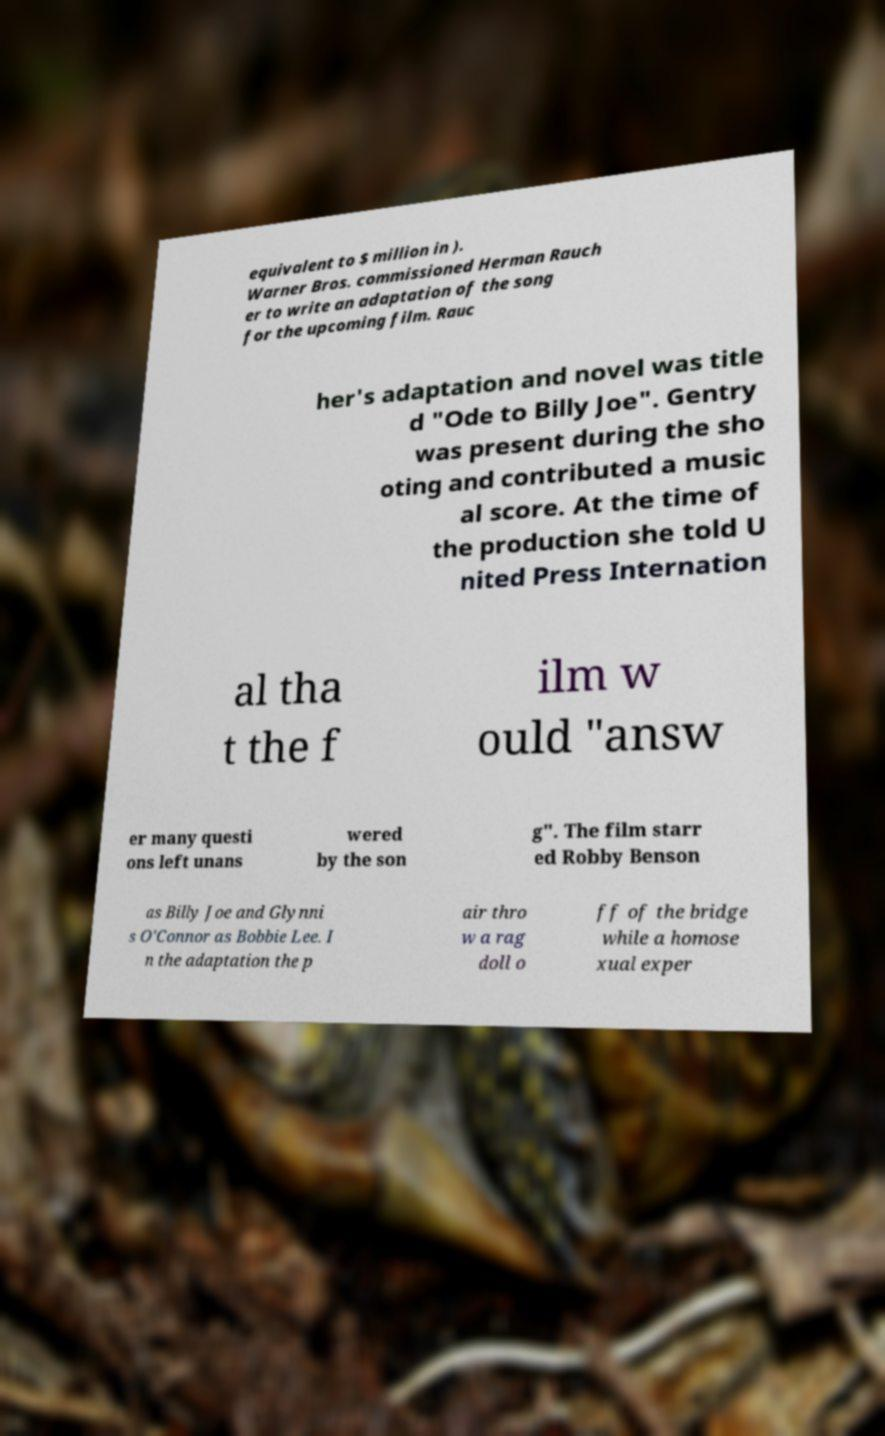There's text embedded in this image that I need extracted. Can you transcribe it verbatim? equivalent to $ million in ). Warner Bros. commissioned Herman Rauch er to write an adaptation of the song for the upcoming film. Rauc her's adaptation and novel was title d "Ode to Billy Joe". Gentry was present during the sho oting and contributed a music al score. At the time of the production she told U nited Press Internation al tha t the f ilm w ould "answ er many questi ons left unans wered by the son g". The film starr ed Robby Benson as Billy Joe and Glynni s O'Connor as Bobbie Lee. I n the adaptation the p air thro w a rag doll o ff of the bridge while a homose xual exper 